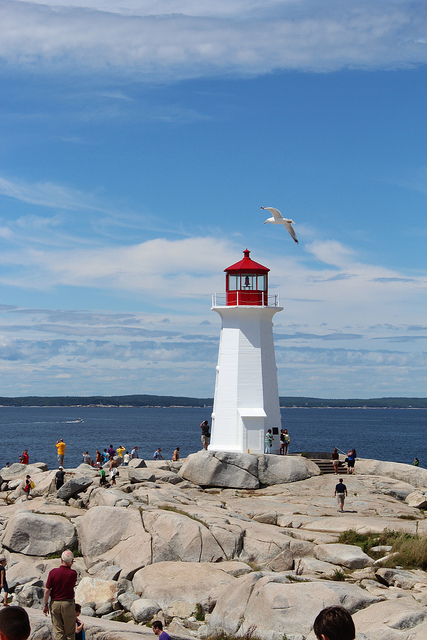What kind of weather do we have in the picture? The weather appears pleasant with a clear blue sky, indicative of a sunny day, which is perfect for outdoor activities like visiting a lighthouse as seen in the image. 